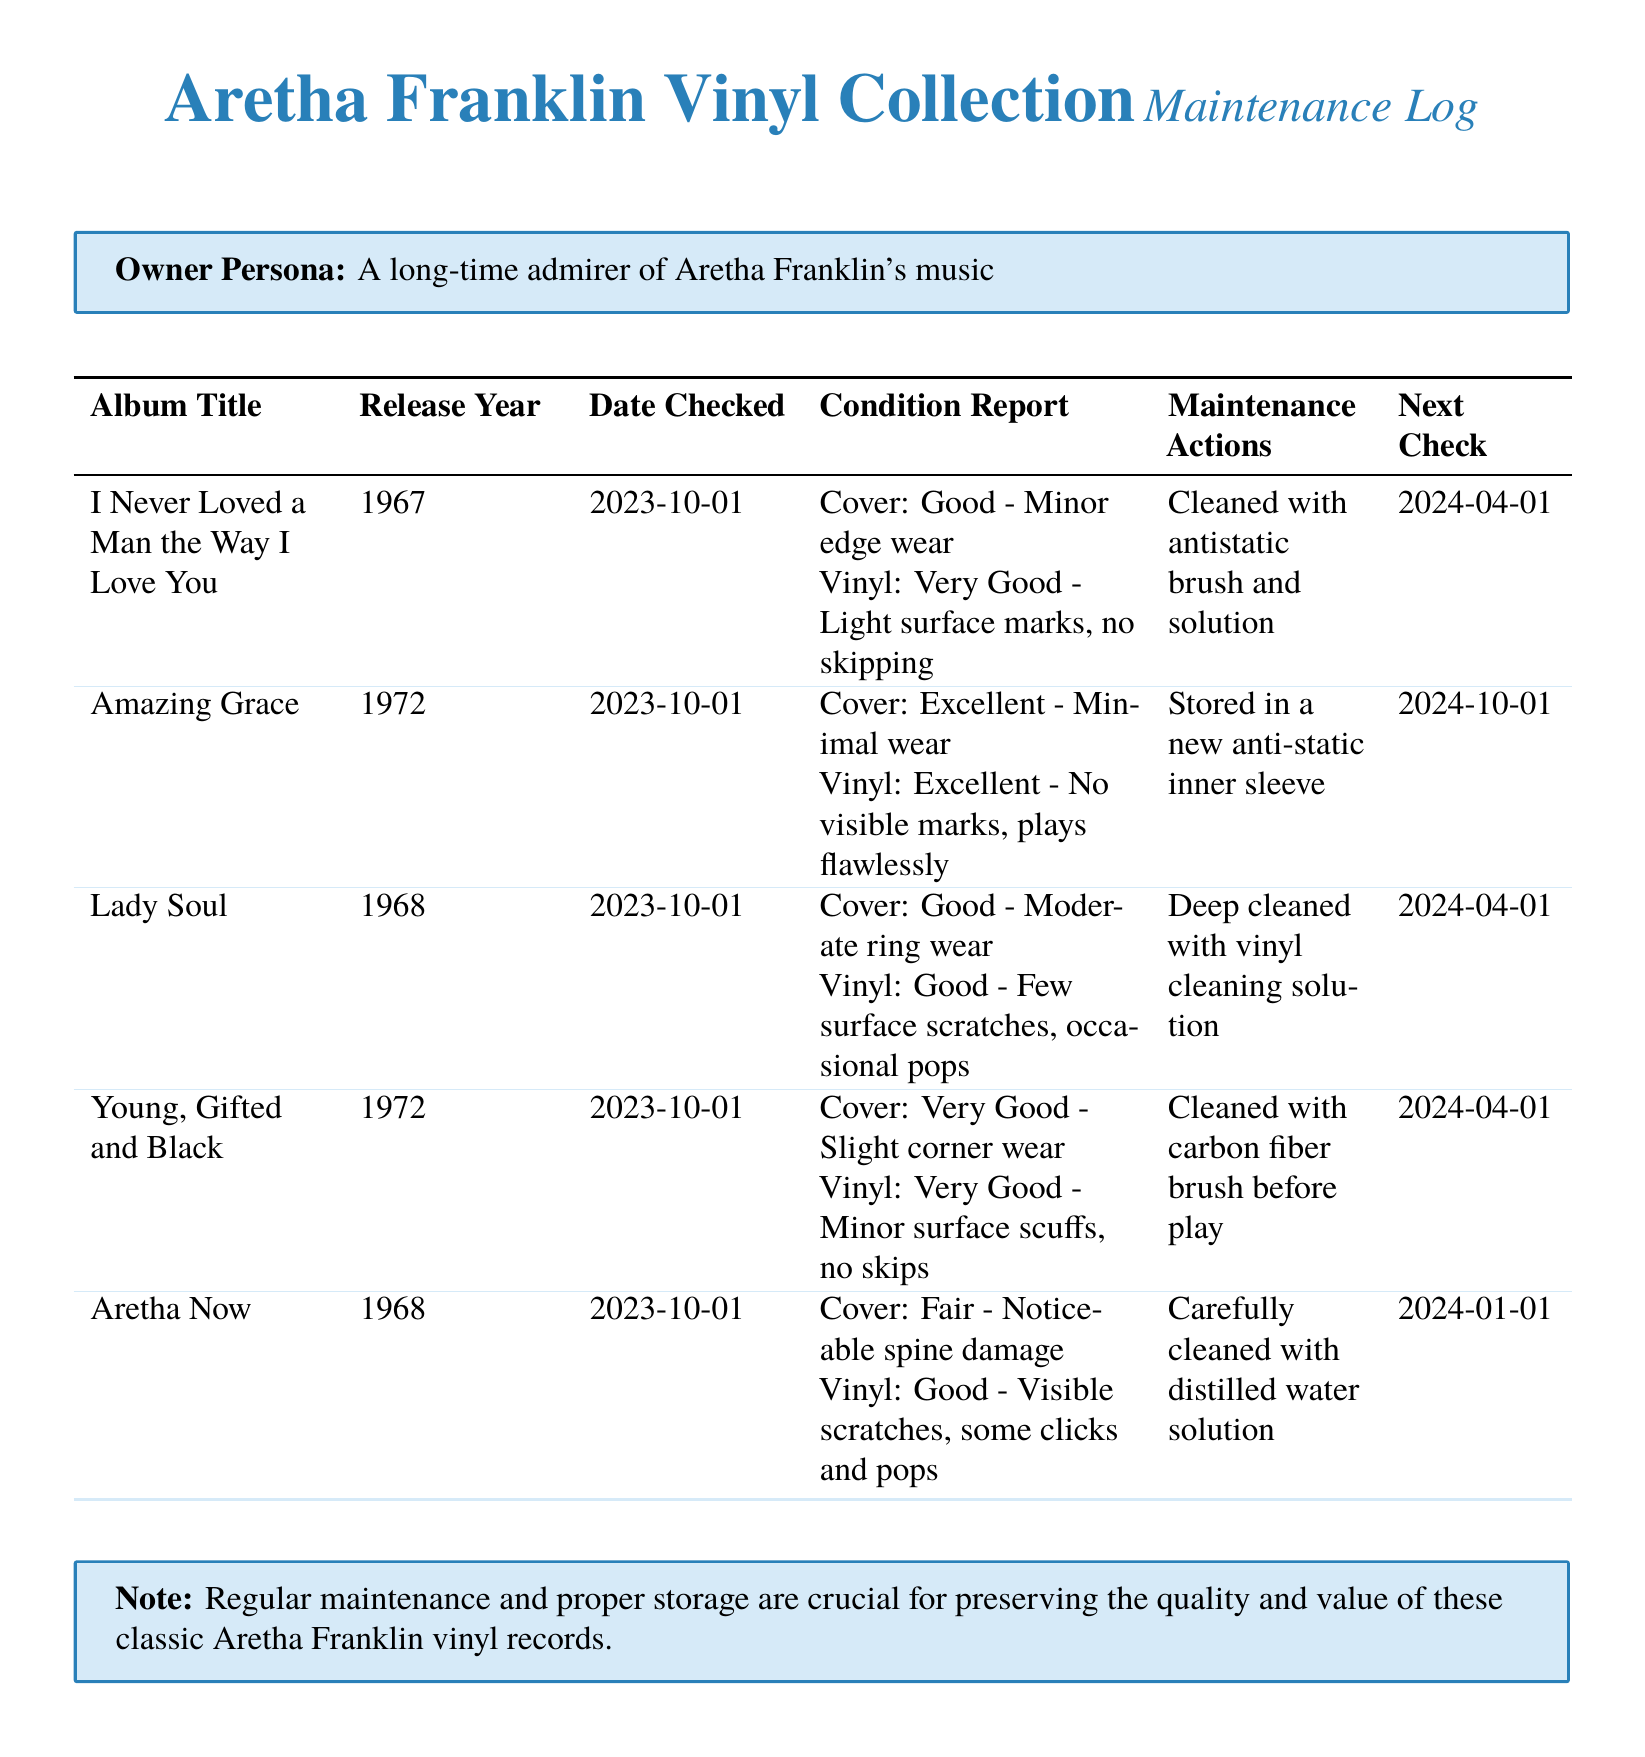What is the title of the album released in 1967? The document specifies that the album titled "I Never Loved a Man the Way I Love You" was released in 1967.
Answer: I Never Loved a Man the Way I Love You What is the condition of the vinyl for "Amazing Grace"? According to the condition report, the vinyl condition of "Amazing Grace" is listed as Excellent, with no visible marks and plays flawlessly.
Answer: Excellent When was the last maintenance check performed for "Lady Soul"? The maintenance log indicates that "Lady Soul" was last checked on 2023-10-01.
Answer: 2023-10-01 What maintenance action was taken for "Aretha Now"? The document states that "Aretha Now" was carefully cleaned with distilled water solution as a maintenance action.
Answer: Carefully cleaned with distilled water solution What is the next check date for "Young, Gifted and Black"? The next check date for "Young, Gifted and Black" is specified as 2024-04-01 in the maintenance log.
Answer: 2024-04-01 Which album has moderate ring wear? The condition report for "Lady Soul" mentions that it has moderate ring wear.
Answer: Lady Soul What is the condition of the cover for "I Never Loved a Man the Way I Love You"? The condition report indicates that the cover of "I Never Loved a Man the Way I Love You" is in Good condition with minor edge wear.
Answer: Good What type of storage was used for "Amazing Grace"? The maintenance log states that "Amazing Grace" was stored in a new anti-static inner sleeve.
Answer: New anti-static inner sleeve Which vinyl had visible scratches and some clicks and pops? The vinyl for "Aretha Now" is reported to have visible scratches and some clicks and pops.
Answer: Aretha Now 